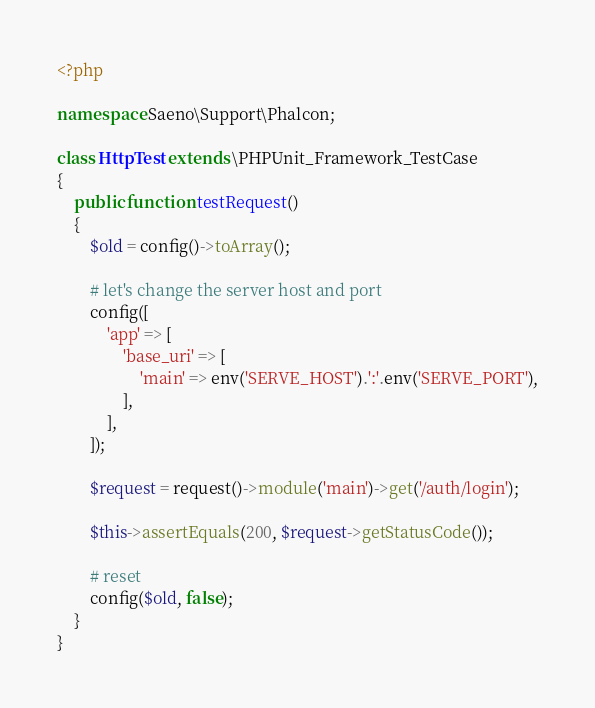Convert code to text. <code><loc_0><loc_0><loc_500><loc_500><_PHP_><?php

namespace Saeno\Support\Phalcon;

class HttpTest extends \PHPUnit_Framework_TestCase
{
    public function testRequest()
    {
        $old = config()->toArray();

        # let's change the server host and port
        config([
            'app' => [
                'base_uri' => [
                    'main' => env('SERVE_HOST').':'.env('SERVE_PORT'),
                ],
            ],
        ]);

        $request = request()->module('main')->get('/auth/login');

        $this->assertEquals(200, $request->getStatusCode());

        # reset
        config($old, false);
    }
}
</code> 